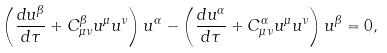Convert formula to latex. <formula><loc_0><loc_0><loc_500><loc_500>\left ( \frac { d u ^ { \beta } } { d \tau } + C ^ { \beta } _ { \mu \nu } u ^ { \mu } u ^ { \nu } \right ) u ^ { \alpha } - \left ( \frac { d u ^ { \alpha } } { d \tau } + C ^ { \alpha } _ { \mu \nu } u ^ { \mu } u ^ { \nu } \right ) u ^ { \beta } = 0 ,</formula> 